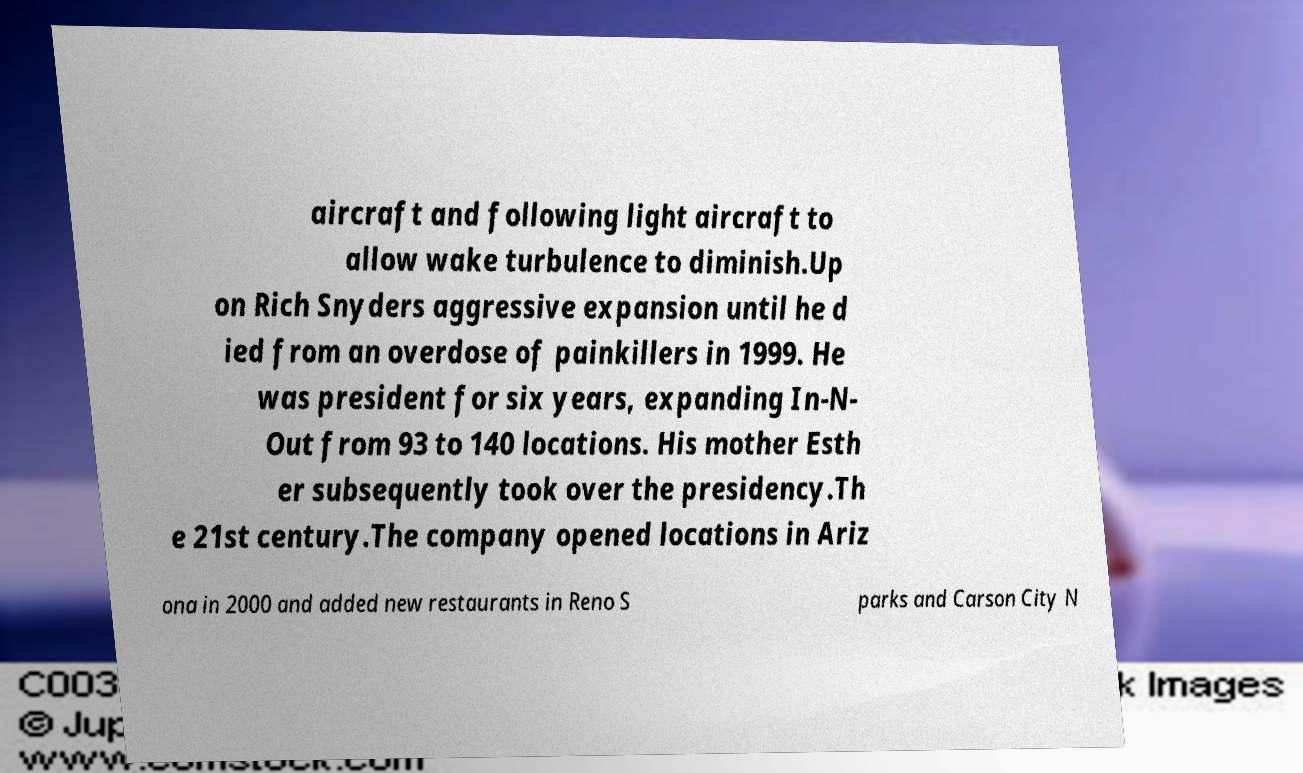Could you extract and type out the text from this image? aircraft and following light aircraft to allow wake turbulence to diminish.Up on Rich Snyders aggressive expansion until he d ied from an overdose of painkillers in 1999. He was president for six years, expanding In-N- Out from 93 to 140 locations. His mother Esth er subsequently took over the presidency.Th e 21st century.The company opened locations in Ariz ona in 2000 and added new restaurants in Reno S parks and Carson City N 